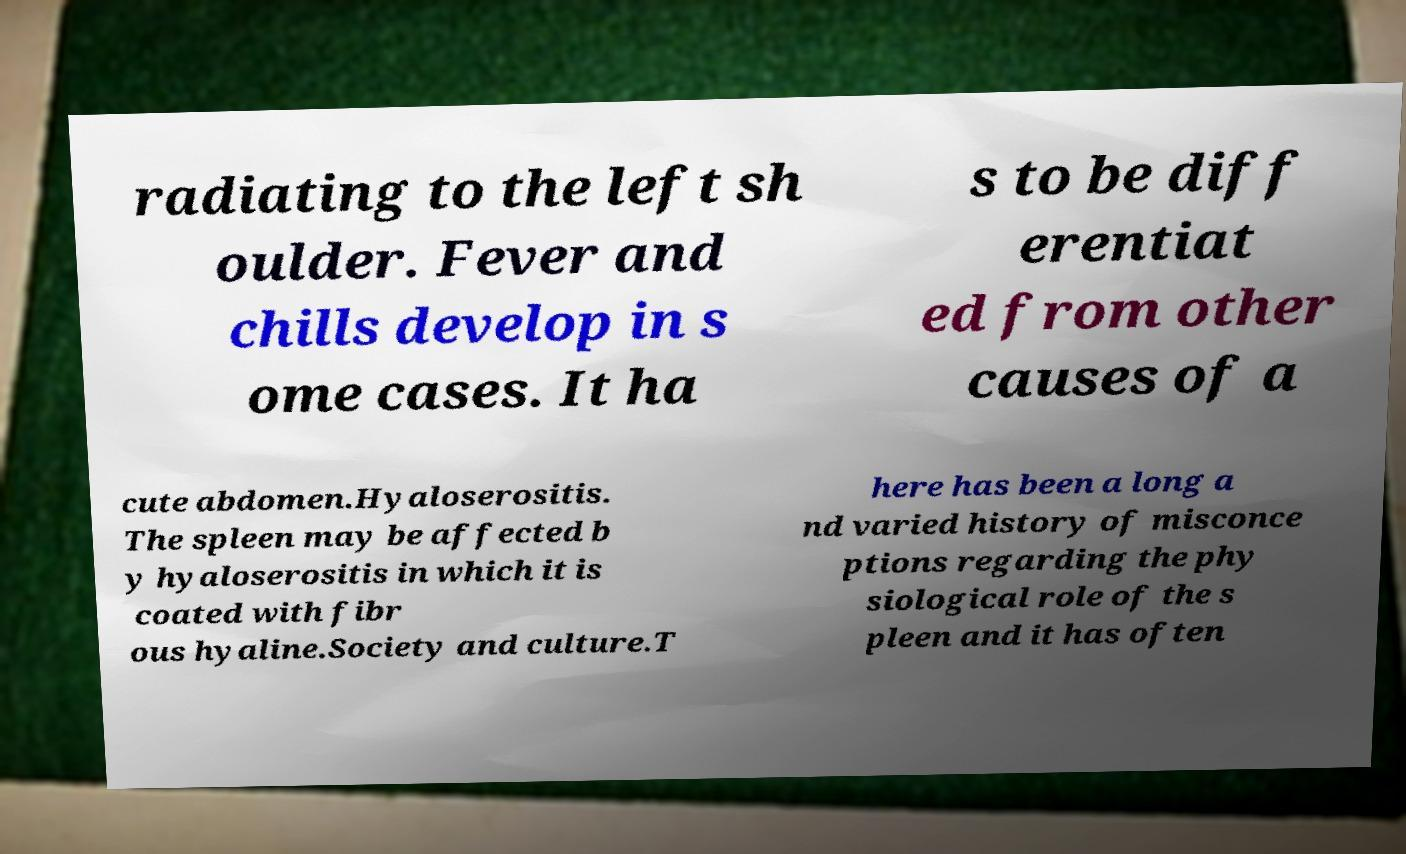There's text embedded in this image that I need extracted. Can you transcribe it verbatim? radiating to the left sh oulder. Fever and chills develop in s ome cases. It ha s to be diff erentiat ed from other causes of a cute abdomen.Hyaloserositis. The spleen may be affected b y hyaloserositis in which it is coated with fibr ous hyaline.Society and culture.T here has been a long a nd varied history of misconce ptions regarding the phy siological role of the s pleen and it has often 